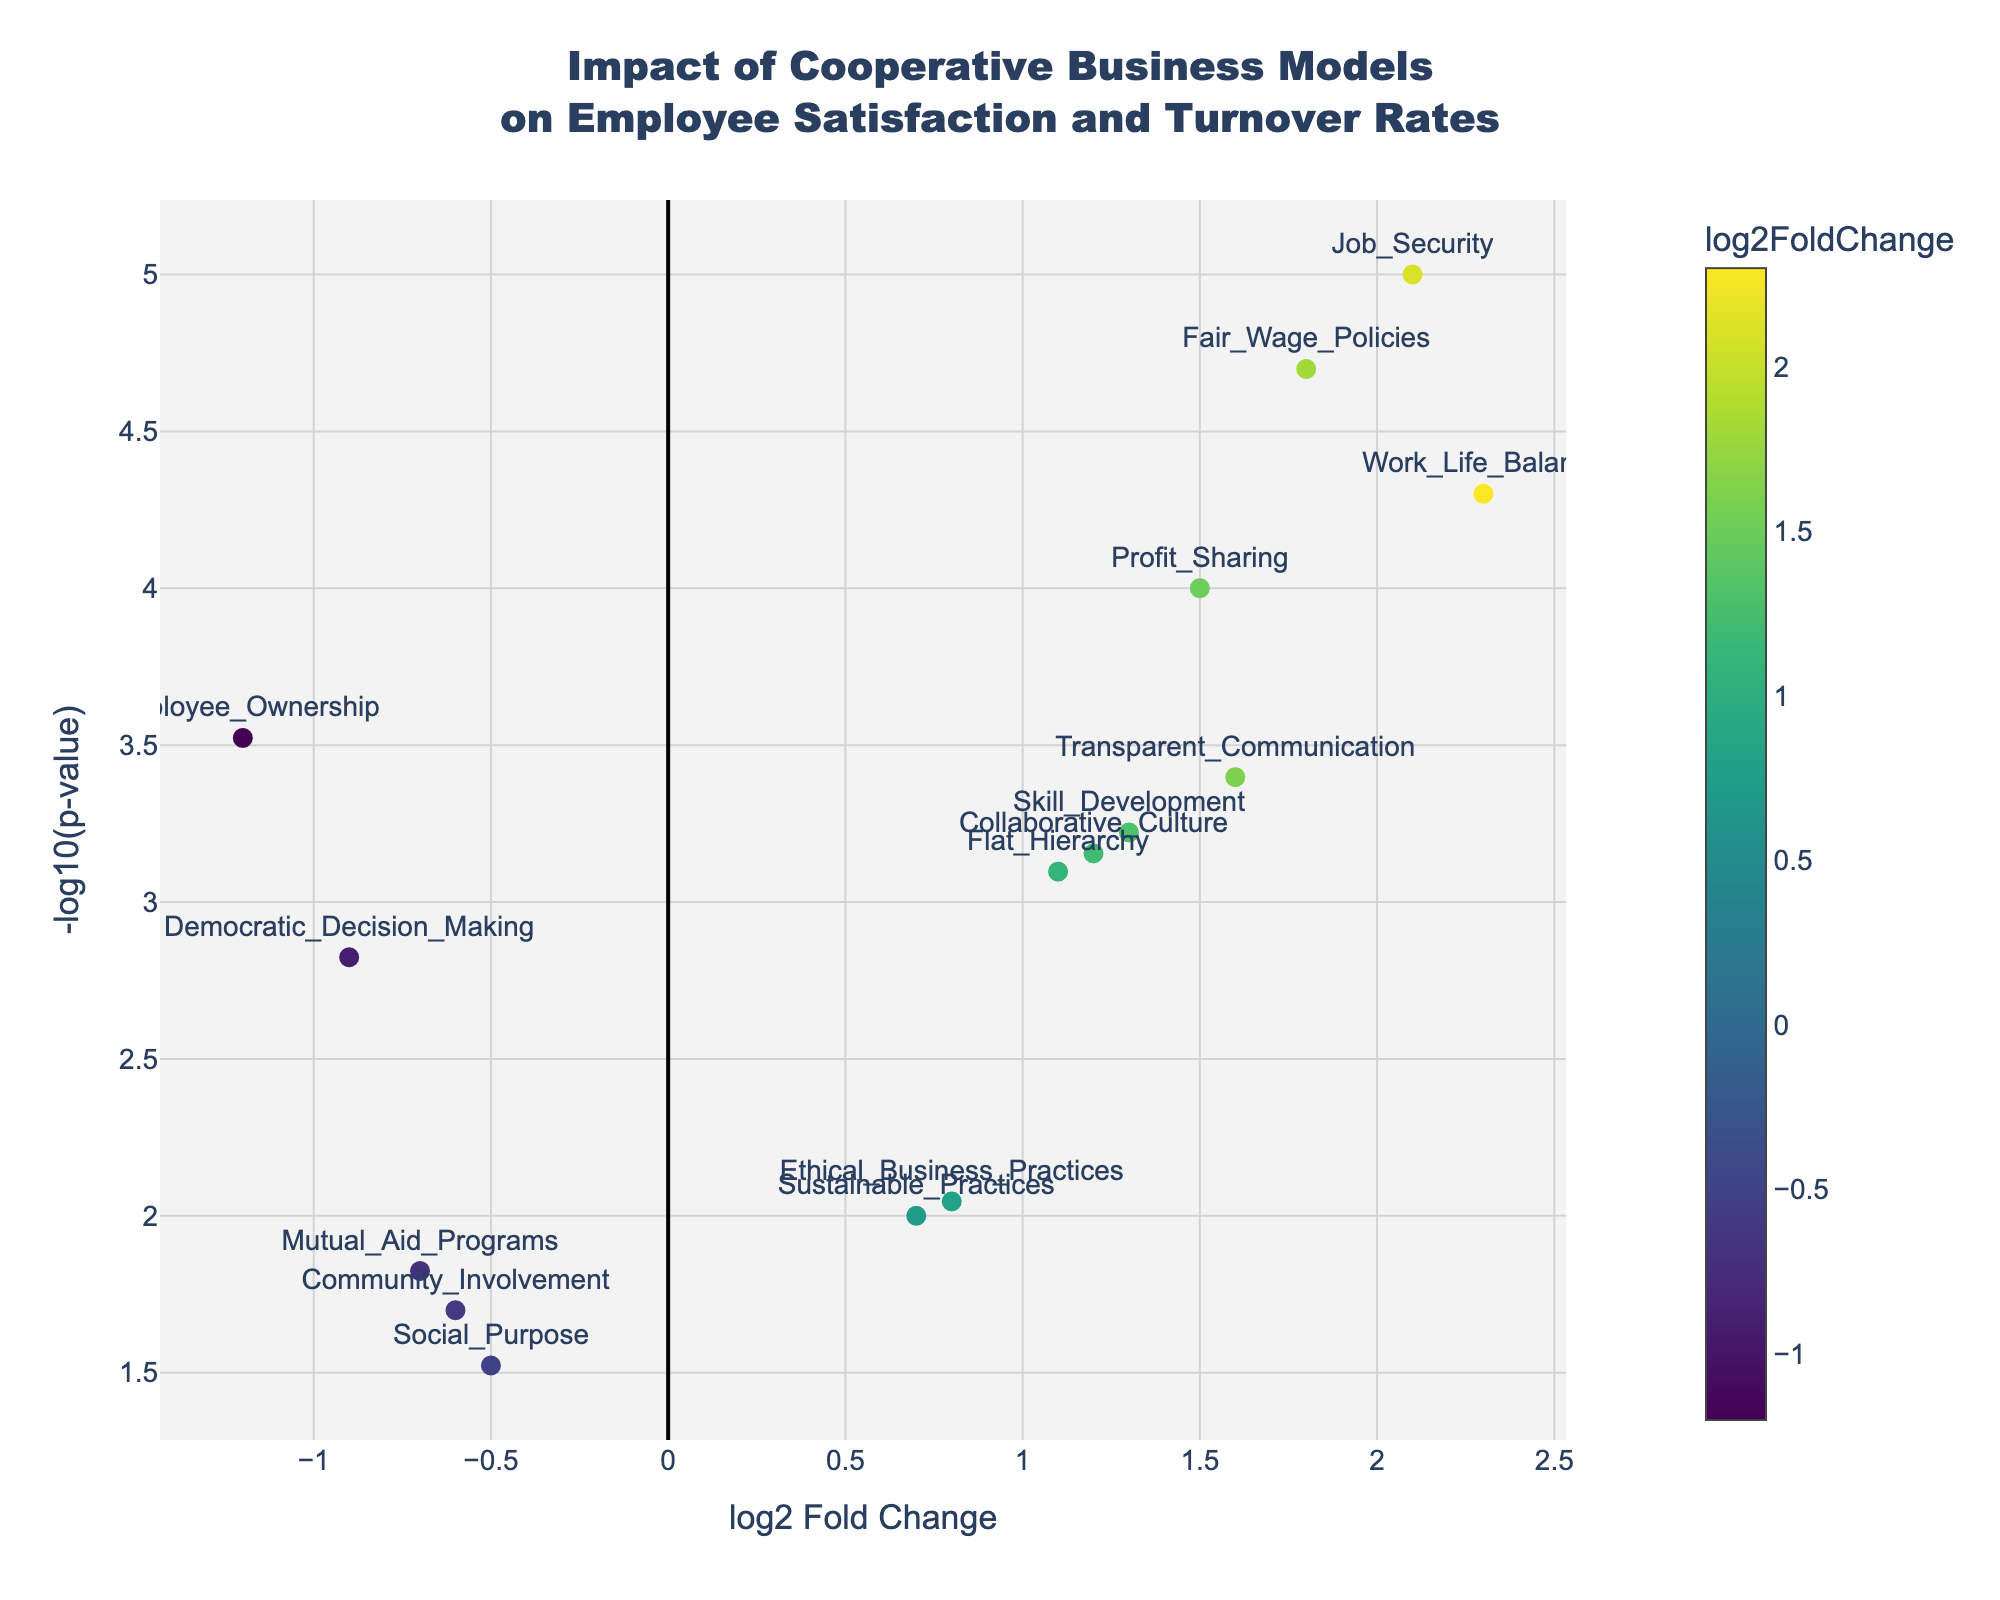What is the title of the plot? The title is located at the top of the plot. It usually gives a concise summary of the plot’s purpose or what the data represents. For this plot, it reads, "Impact of Cooperative Business Models on Employee Satisfaction and Turnover Rates"
Answer: Impact of Cooperative Business Models on Employee Satisfaction and Turnover Rates How many data points have a positive log2 Fold Change? Observe the x-axis, where positive values represent positive log2 Fold Change. Count the number of data points right of zero on the x-axis. There are 10 such points.
Answer: 10 Which business model has the highest -log10(p-value)? The highest -log10(p-value) can be identified by locating the highest point on the y-axis. The corresponding data point is associated with "Job_Security".
Answer: Job_Security What is the log2 Fold Change for "Work_Life_Balance"? Locate "Work_Life_Balance" on the plot. Its position on the x-axis provides the log2 Fold Change. The log2 Fold Change is 2.3.
Answer: 2.3 Which business model has the lowest p-value? Since p-value is plotted as -log10(p-value), the lowest p-value will correspond to the highest y-axis value. This is for "Job_Security".
Answer: Job_Security Comparing "Flat_Hierarchy" and "Employee_Ownership", which has a larger impact on employee satisfaction? Compare the log2 Fold Change values for both models. "Flat_Hierarchy" has a log2 Fold Change of 1.1, while "Employee_Ownership" has a log2 Fold Change of -1.2. A higher log2 Fold Change indicates a larger positive impact.
Answer: Flat_Hierarchy Which business models have a significant negative impact on employee satisfaction? Significant negative impact is indicated by negative log2 Fold Change values and highly significant p-values (high -log10 values). These business models are "Employee_Ownership," "Democratic_Decision_Making," "Community_Involvement," "Social_Purpose," and "Mutual_Aid_Programs".
Answer: Employee_Ownership, Democratic_Decision_Making, Community_Involvement, Social_Purpose, Mutual_Aid_Programs What is the overall trend shown in the plot regarding the impact of cooperative business models? By observing the spread of data points, evaluate the general direction and concentration. Most points with a high -log10(p-value) demonstrate a positive log2 Fold Change, indicating an overall positive impact of cooperative business models on employee satisfaction.
Answer: Overall positive impact Explain how to interpret a data point at (log2 Fold Change = 1.0, -log10(p-value) = 2.0) The log2 Fold Change of 1.0 indicates a doubling in the metric of interest (e.g., employee satisfaction) due to the business model change. The -log10(p-value) of 2.0 signifies a p-value of 0.01, which is statistically significant.
Answer: Doubling in metric with p-value of 0.01 